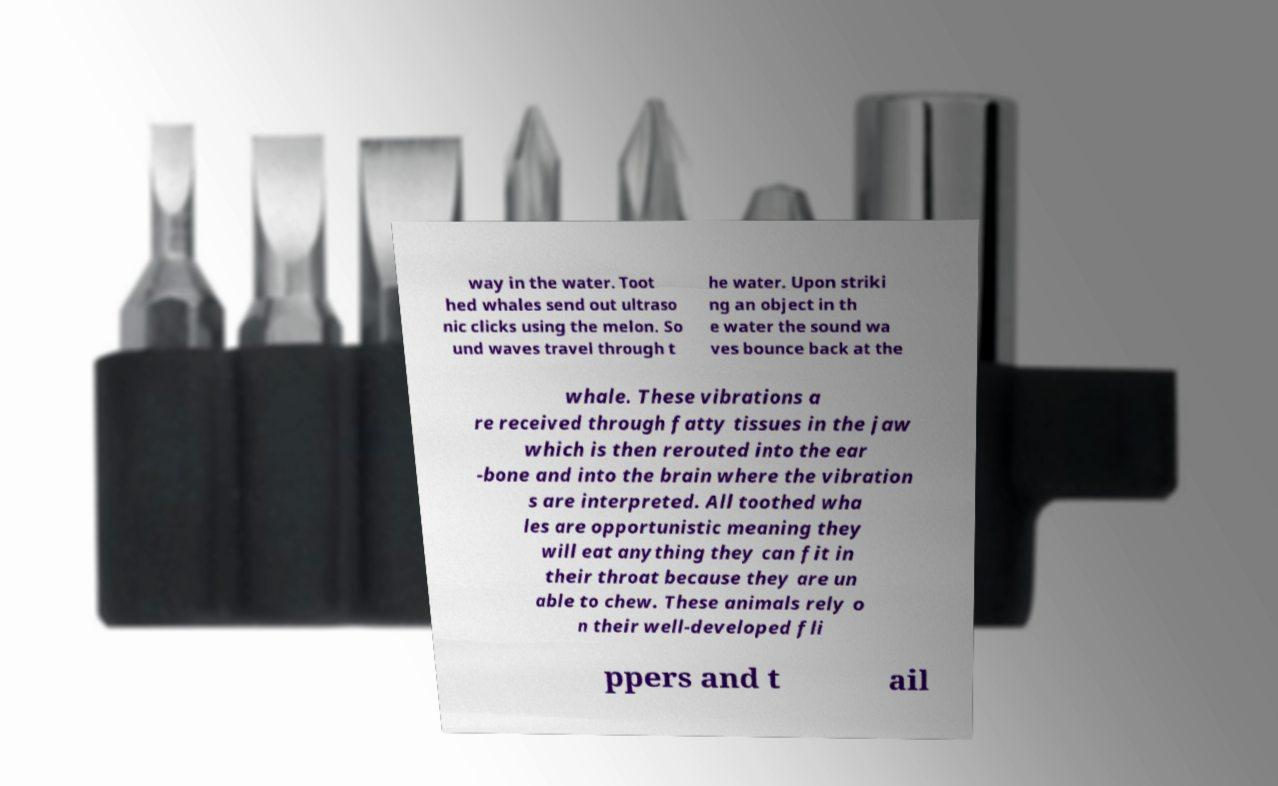Can you read and provide the text displayed in the image?This photo seems to have some interesting text. Can you extract and type it out for me? way in the water. Toot hed whales send out ultraso nic clicks using the melon. So und waves travel through t he water. Upon striki ng an object in th e water the sound wa ves bounce back at the whale. These vibrations a re received through fatty tissues in the jaw which is then rerouted into the ear -bone and into the brain where the vibration s are interpreted. All toothed wha les are opportunistic meaning they will eat anything they can fit in their throat because they are un able to chew. These animals rely o n their well-developed fli ppers and t ail 